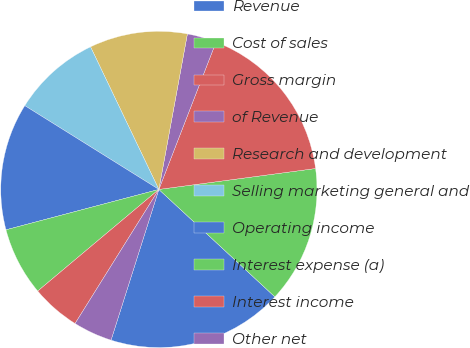Convert chart. <chart><loc_0><loc_0><loc_500><loc_500><pie_chart><fcel>Revenue<fcel>Cost of sales<fcel>Gross margin<fcel>of Revenue<fcel>Research and development<fcel>Selling marketing general and<fcel>Operating income<fcel>Interest expense (a)<fcel>Interest income<fcel>Other net<nl><fcel>18.0%<fcel>14.0%<fcel>17.0%<fcel>3.0%<fcel>10.0%<fcel>9.0%<fcel>13.0%<fcel>7.0%<fcel>5.0%<fcel>4.0%<nl></chart> 